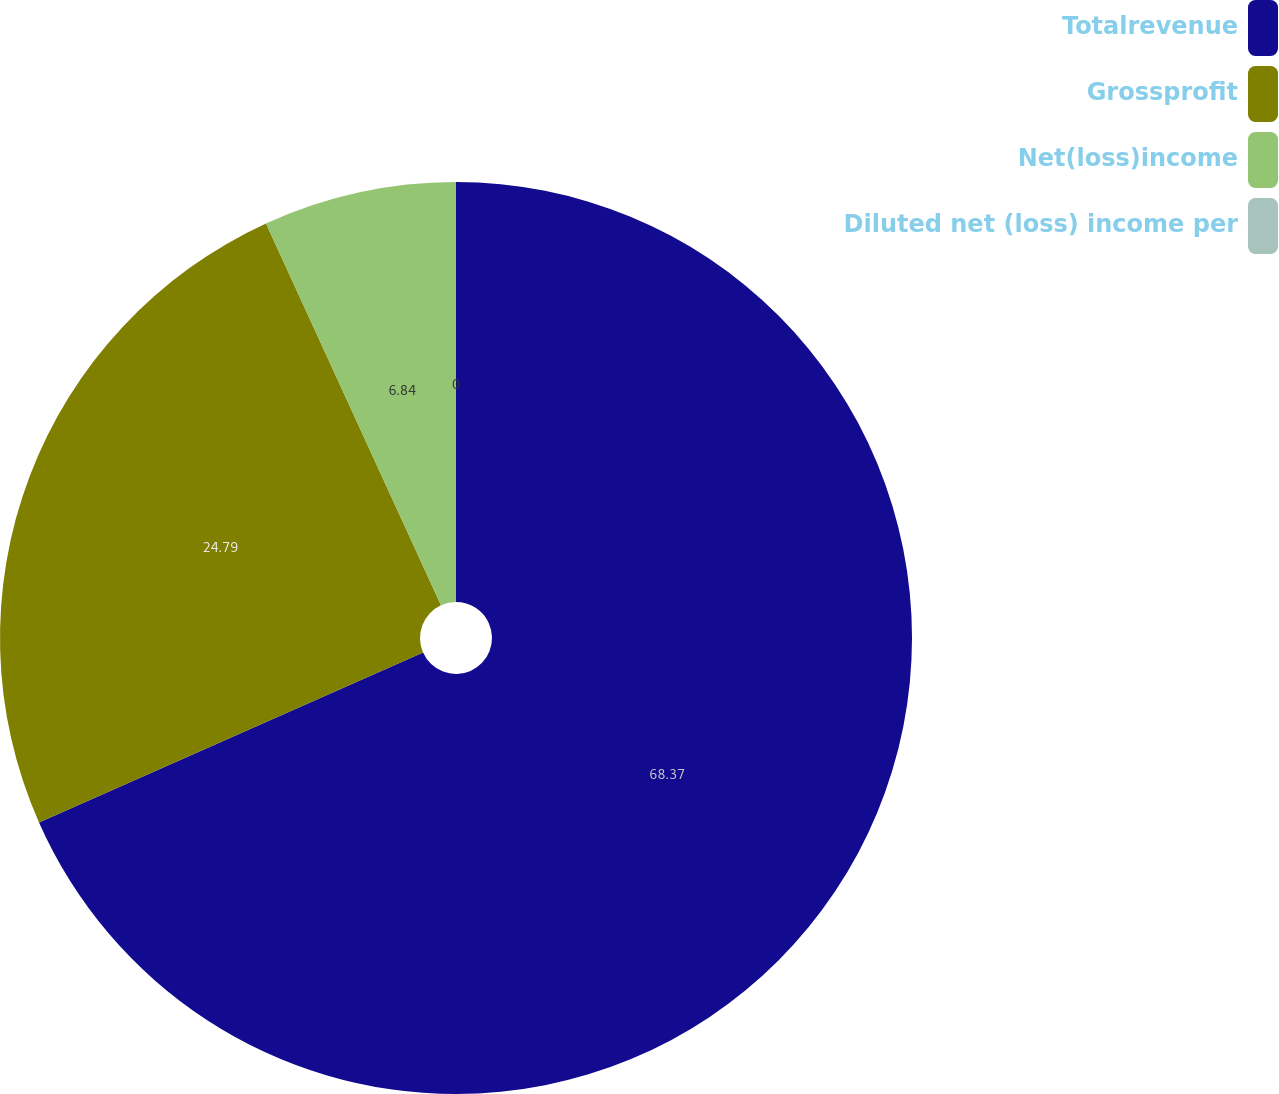<chart> <loc_0><loc_0><loc_500><loc_500><pie_chart><fcel>Totalrevenue<fcel>Grossprofit<fcel>Net(loss)income<fcel>Diluted net (loss) income per<nl><fcel>68.37%<fcel>24.79%<fcel>6.84%<fcel>0.0%<nl></chart> 